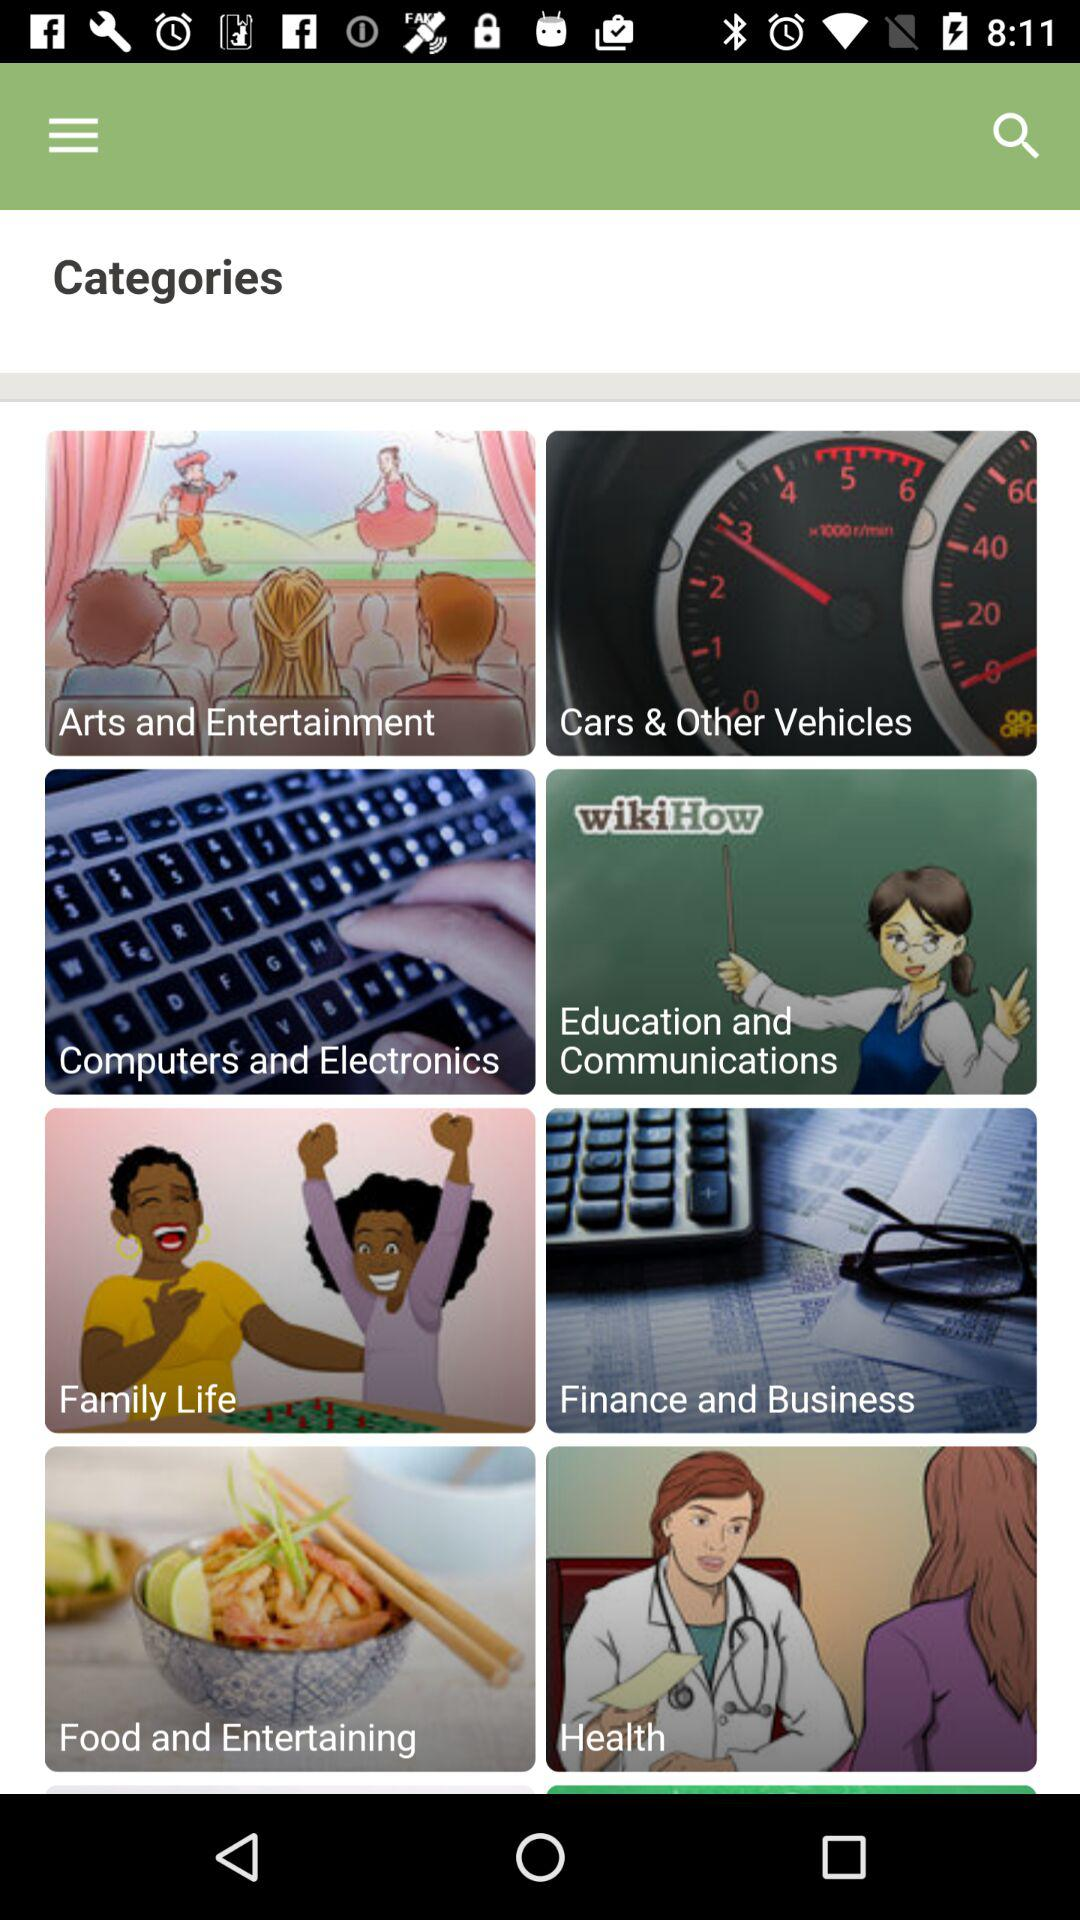How many categories are there in total?
Answer the question using a single word or phrase. 8 